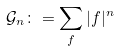Convert formula to latex. <formula><loc_0><loc_0><loc_500><loc_500>\mathcal { \mathcal { G } } _ { n } \colon = \sum _ { f } | f | ^ { n }</formula> 